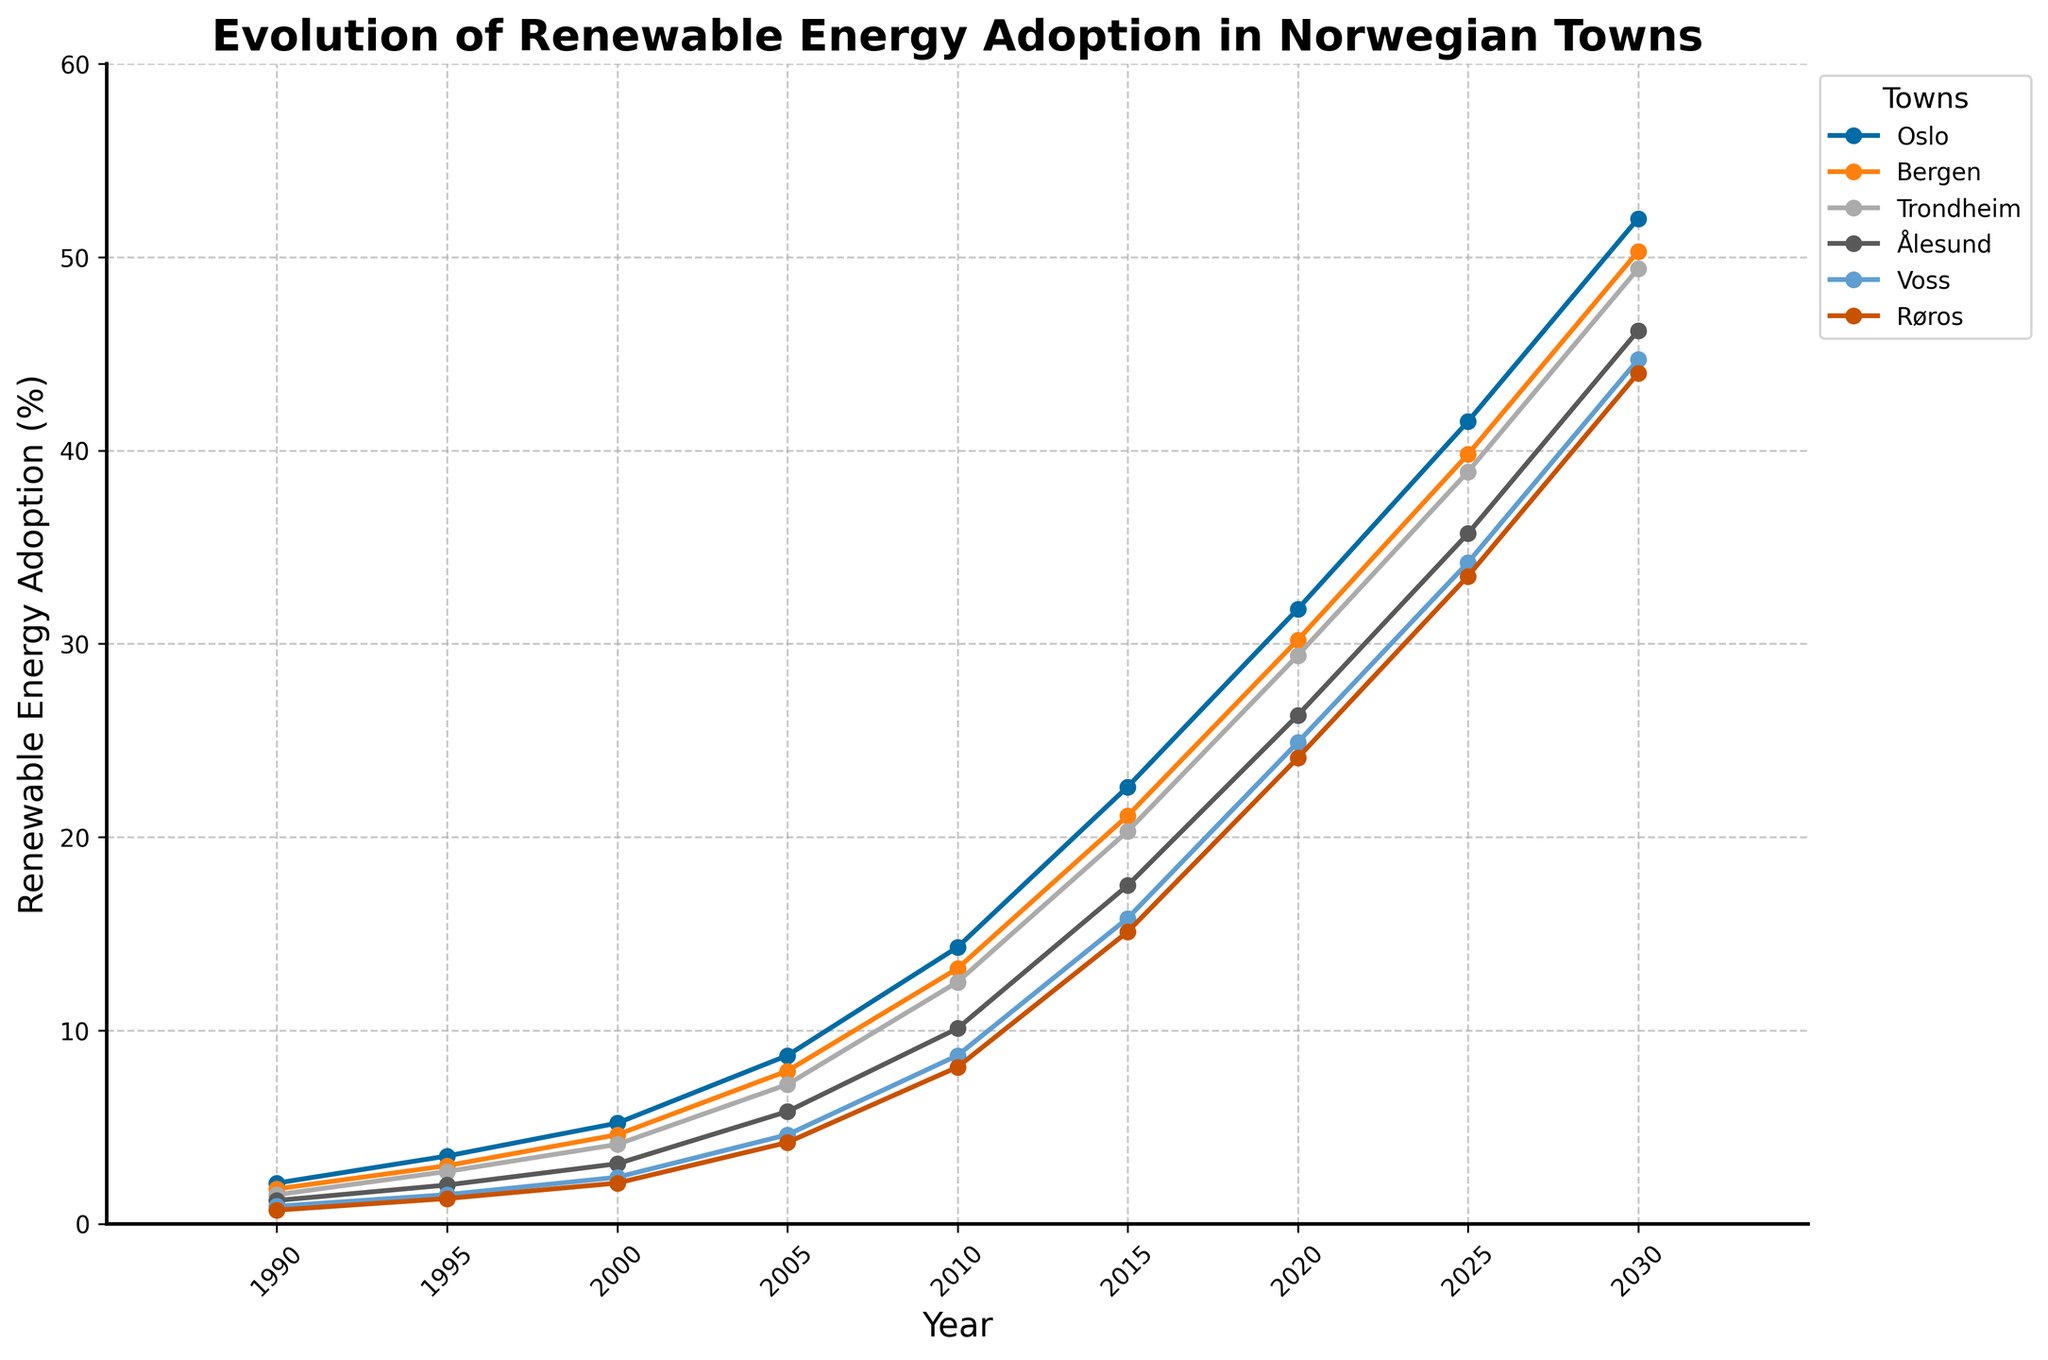What was the trend in renewable energy adoption for Oslo from 1990 to 2030? By observing the line representing Oslo, it's clear that the adoption of renewable energy increased steadily from 2.1% in 1990 to 52.0% in 2030. The upward trend is consistent throughout the years.
Answer: Increasing steadily Which town had the highest renewable energy adoption rate in 2020? Looking at the data points for 2020, Oslo has the highest adoption rate at 31.8%, compared to all the other towns.
Answer: Oslo In which year did Ålesund's renewable energy adoption rate surpass 10%? By visually inspecting the figure, Ålesund's adoption rate exceeded 10% in the year 2010, reaching 10.1%.
Answer: 2010 How much greater was the renewable energy adoption rate in Oslo compared to Voss in 2015? Subtract Voss's adoption rate (15.8%) from Oslo's (22.6%) in 2015. Therefore, the difference is 22.6% - 15.8% = 6.8%.
Answer: 6.8% What was the average renewable energy adoption rate for Røros in the years shown? Add all Røros's values and divide by the number of years: (0.7 + 1.3 + 2.1 + 4.2 + 8.1 + 15.1 + 24.1 + 33.5 + 44.0)/9 = 14.57%.
Answer: 14.57% Compare the adoption rates between Bergen and Trondheim in 2005 and calculate the percentage difference. The rates in 2005 were Bergen (7.9%) and Trondheim (7.2%). The percentage difference is (7.9 - 7.2) / 7.2 * 100% = 9.72%.
Answer: 9.72% Which town showed the smallest increase in renewable energy adoption between 1990 and 2025? Røros increased from 0.7% (1990) to 33.5% (2025), an increase of 32.8%. Comparatively, Voss increased by 33.3%, so the smallest increase is seen in Røros.
Answer: Røros Identify the color representing Bergen in the figure. In the figure, the color scheme used follows the 'tableau-colorblind10' style. The line representing Bergen is the second one from Oslo's starting point, suggesting a different color easy to distinguish from others, typically in such themes shown as orange.
Answer: orange 